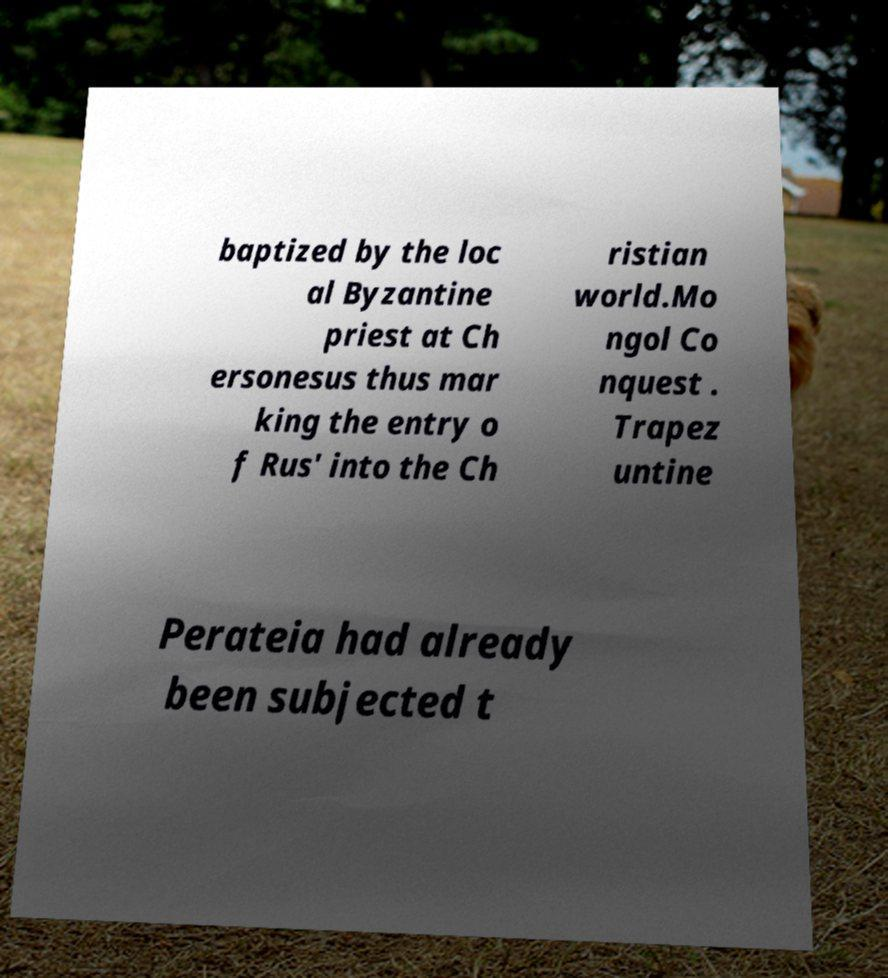Could you extract and type out the text from this image? baptized by the loc al Byzantine priest at Ch ersonesus thus mar king the entry o f Rus' into the Ch ristian world.Mo ngol Co nquest . Trapez untine Perateia had already been subjected t 